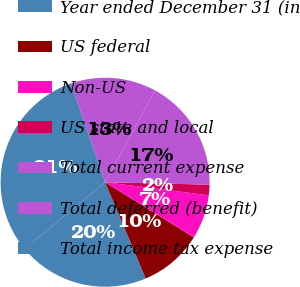Convert chart to OTSL. <chart><loc_0><loc_0><loc_500><loc_500><pie_chart><fcel>Year ended December 31 (in<fcel>US federal<fcel>Non-US<fcel>US state and local<fcel>Total current expense<fcel>Total deferred (benefit)<fcel>Total income tax expense<nl><fcel>20.35%<fcel>9.78%<fcel>6.87%<fcel>1.62%<fcel>17.44%<fcel>13.24%<fcel>30.69%<nl></chart> 